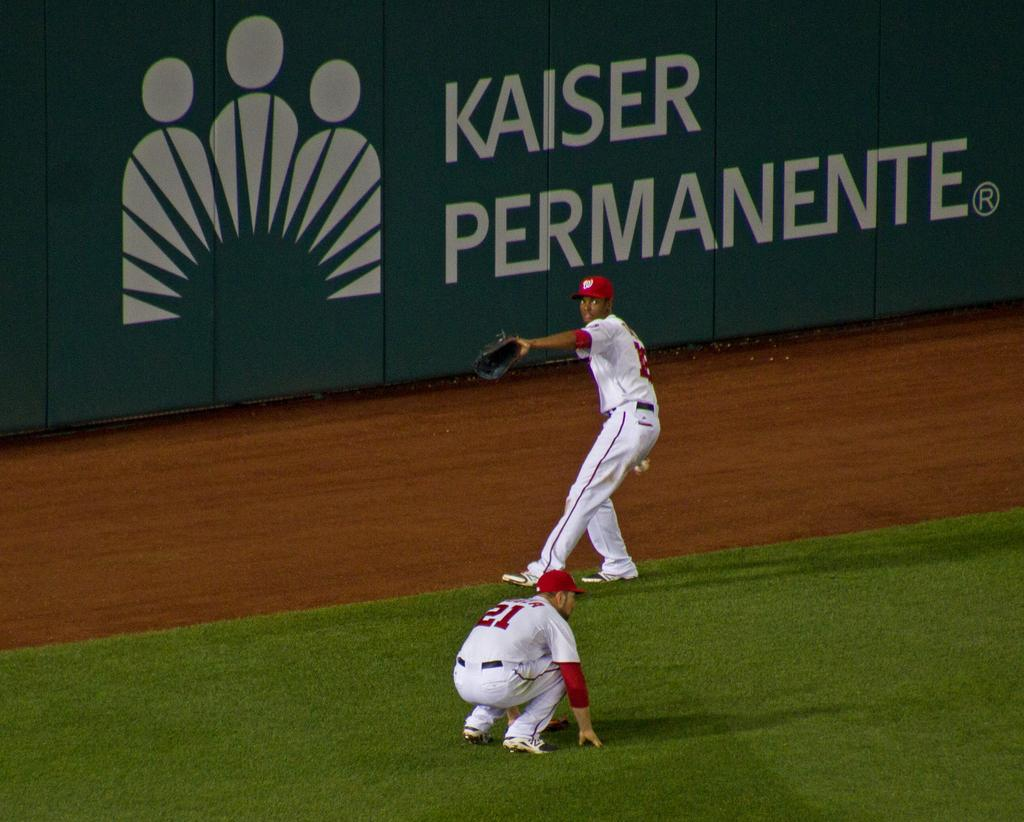Provide a one-sentence caption for the provided image. Two members of a baseball team out in the field with a Kaiser Permanente advertisment directly behind them on the wall. 